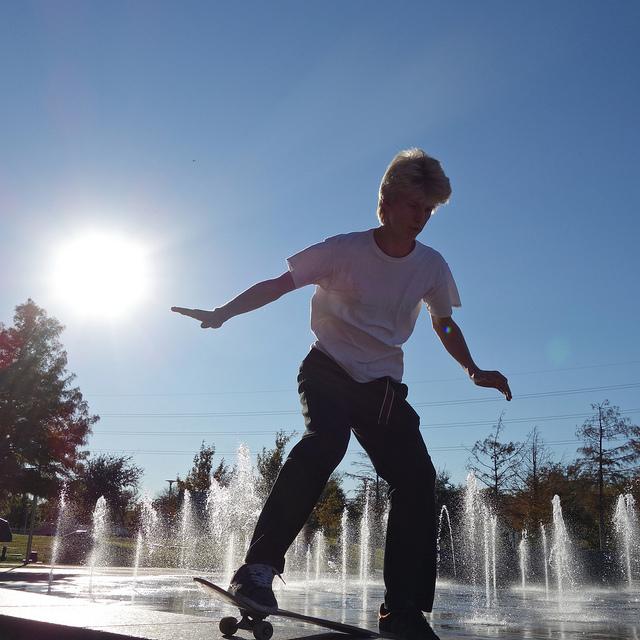What is the glowing object in the background?
Be succinct. Sun. Is this person balanced?
Concise answer only. Yes. Is the person scared to fall?
Short answer required. Yes. 